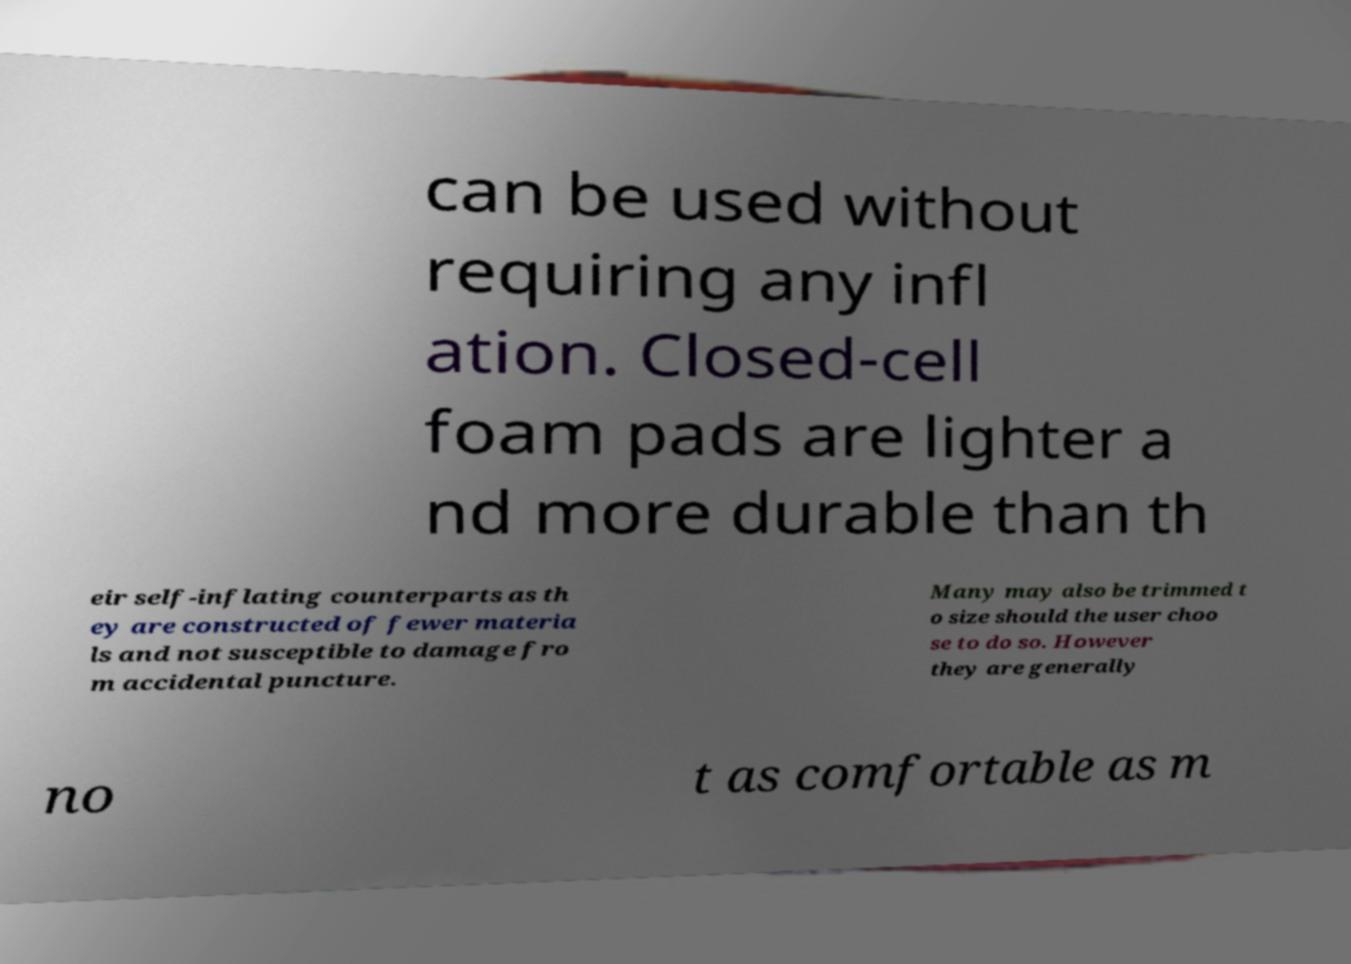What messages or text are displayed in this image? I need them in a readable, typed format. can be used without requiring any infl ation. Closed-cell foam pads are lighter a nd more durable than th eir self-inflating counterparts as th ey are constructed of fewer materia ls and not susceptible to damage fro m accidental puncture. Many may also be trimmed t o size should the user choo se to do so. However they are generally no t as comfortable as m 